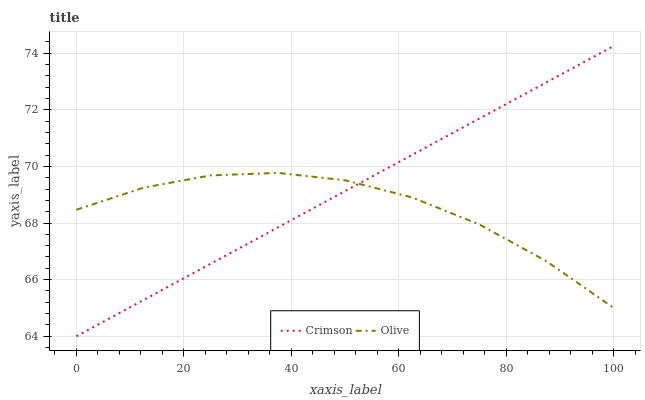Does Olive have the minimum area under the curve?
Answer yes or no. Yes. Does Crimson have the maximum area under the curve?
Answer yes or no. Yes. Does Olive have the maximum area under the curve?
Answer yes or no. No. Is Crimson the smoothest?
Answer yes or no. Yes. Is Olive the roughest?
Answer yes or no. Yes. Is Olive the smoothest?
Answer yes or no. No. Does Crimson have the lowest value?
Answer yes or no. Yes. Does Olive have the lowest value?
Answer yes or no. No. Does Crimson have the highest value?
Answer yes or no. Yes. Does Olive have the highest value?
Answer yes or no. No. Does Olive intersect Crimson?
Answer yes or no. Yes. Is Olive less than Crimson?
Answer yes or no. No. Is Olive greater than Crimson?
Answer yes or no. No. 